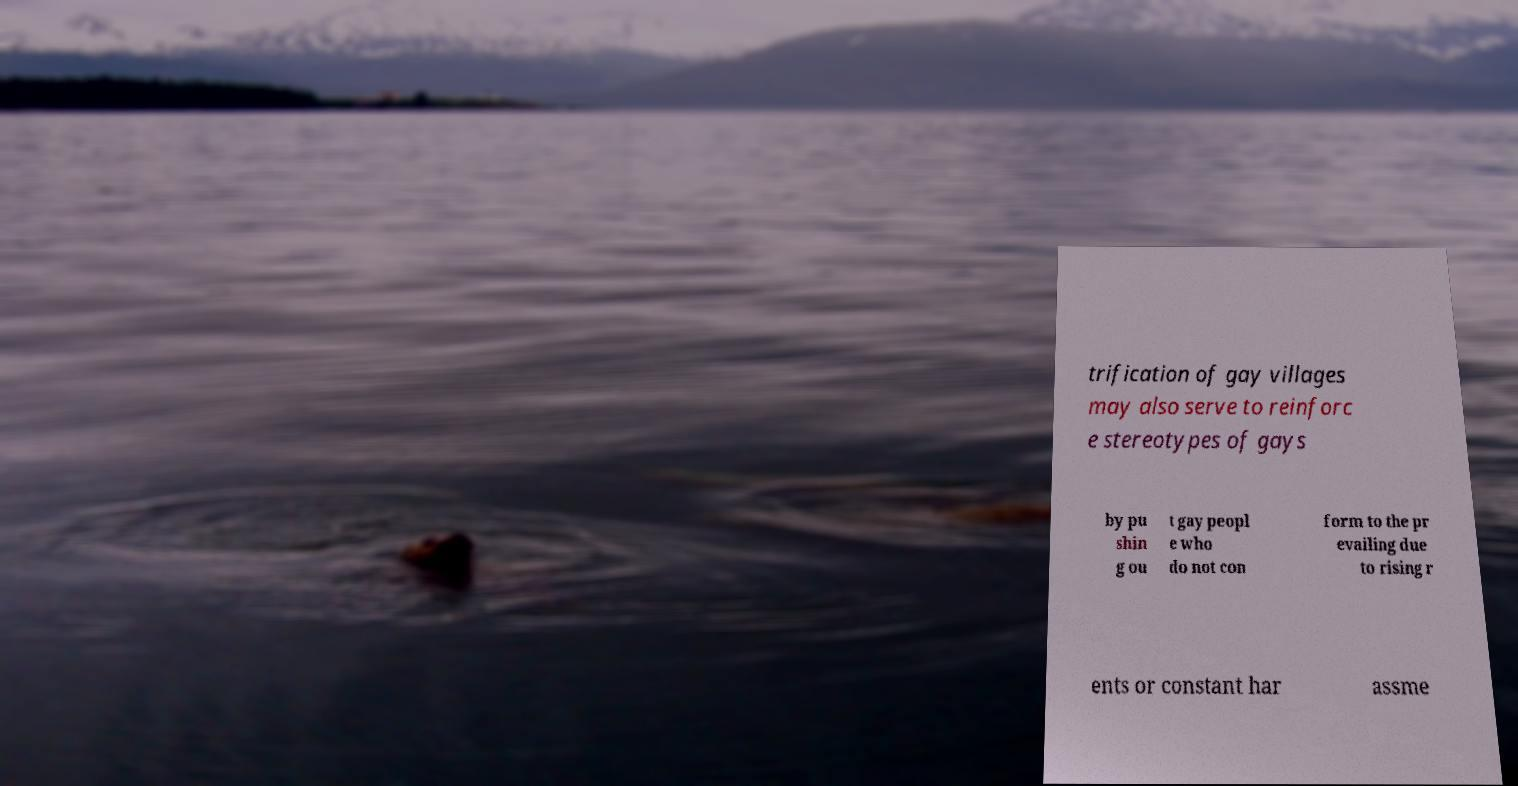Please read and relay the text visible in this image. What does it say? trification of gay villages may also serve to reinforc e stereotypes of gays by pu shin g ou t gay peopl e who do not con form to the pr evailing due to rising r ents or constant har assme 